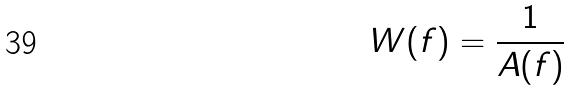Convert formula to latex. <formula><loc_0><loc_0><loc_500><loc_500>W ( f ) = \frac { 1 } { A ( f ) }</formula> 